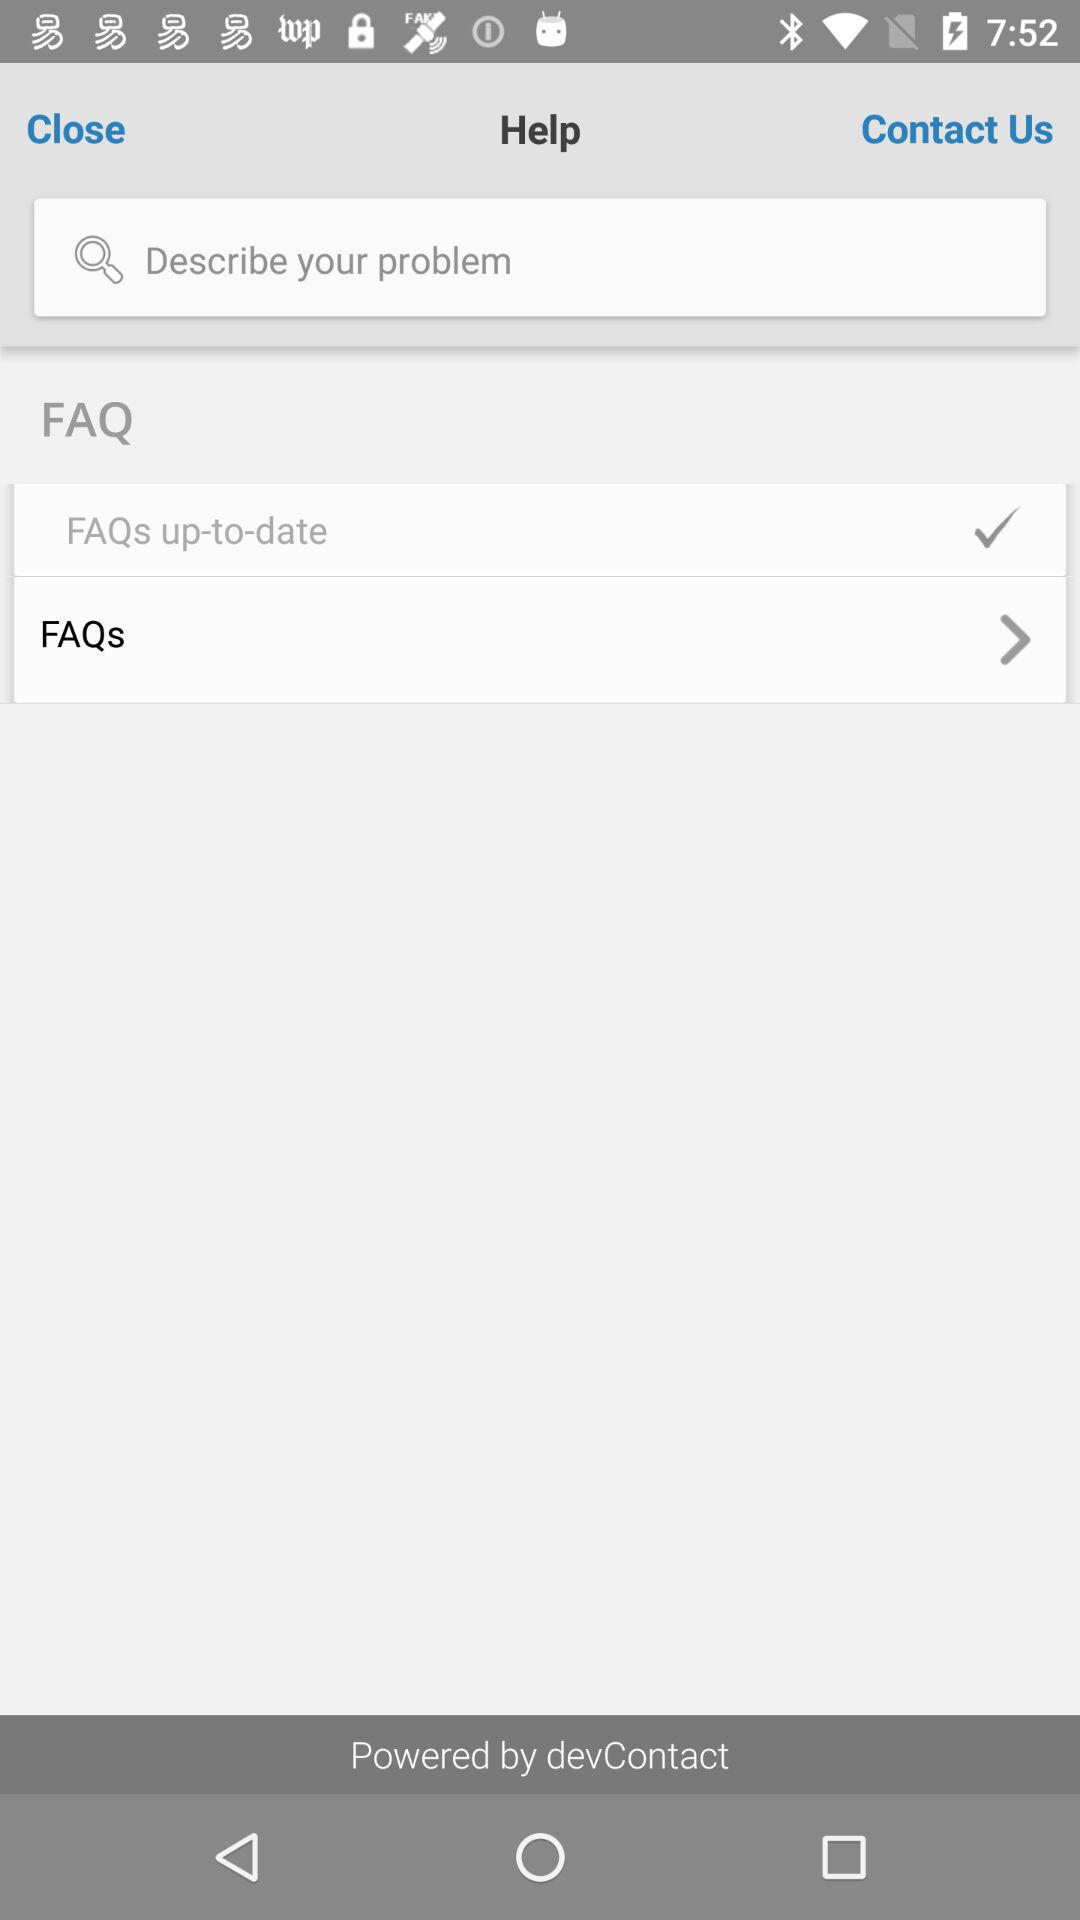It is powered by whom? It is powered by "devContact". 